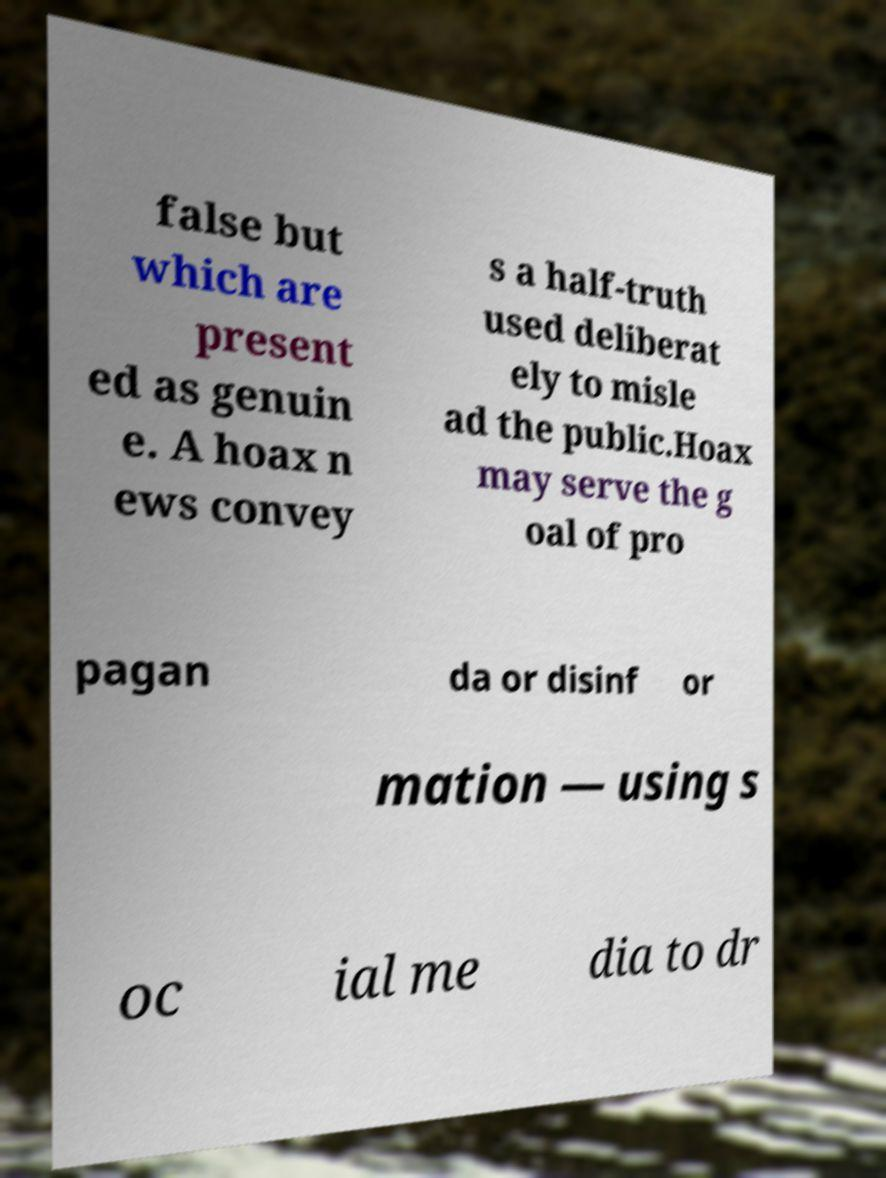Could you assist in decoding the text presented in this image and type it out clearly? false but which are present ed as genuin e. A hoax n ews convey s a half-truth used deliberat ely to misle ad the public.Hoax may serve the g oal of pro pagan da or disinf or mation — using s oc ial me dia to dr 